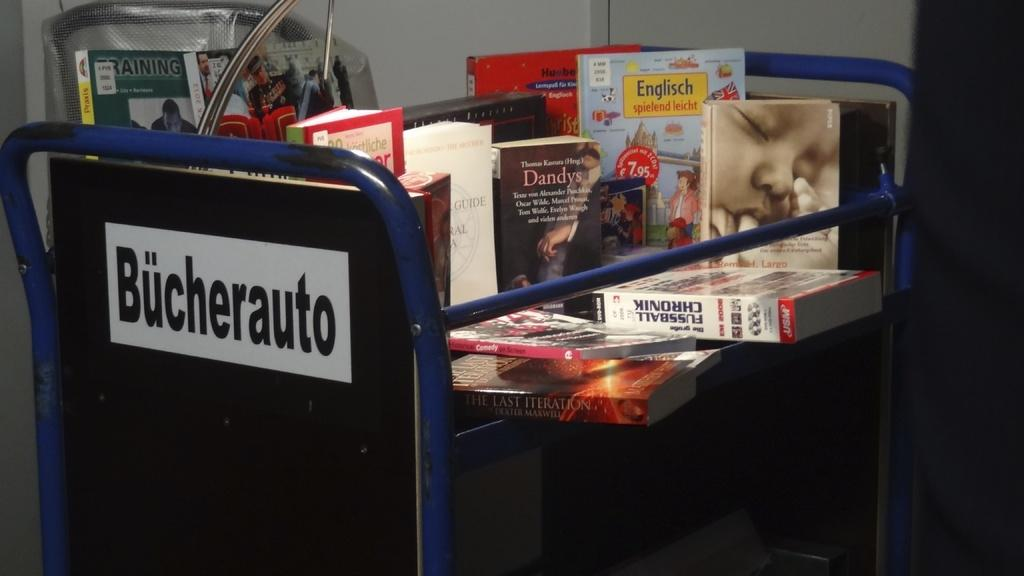<image>
Give a short and clear explanation of the subsequent image. A line of books is stacked up on a cart reading Bucherauto 